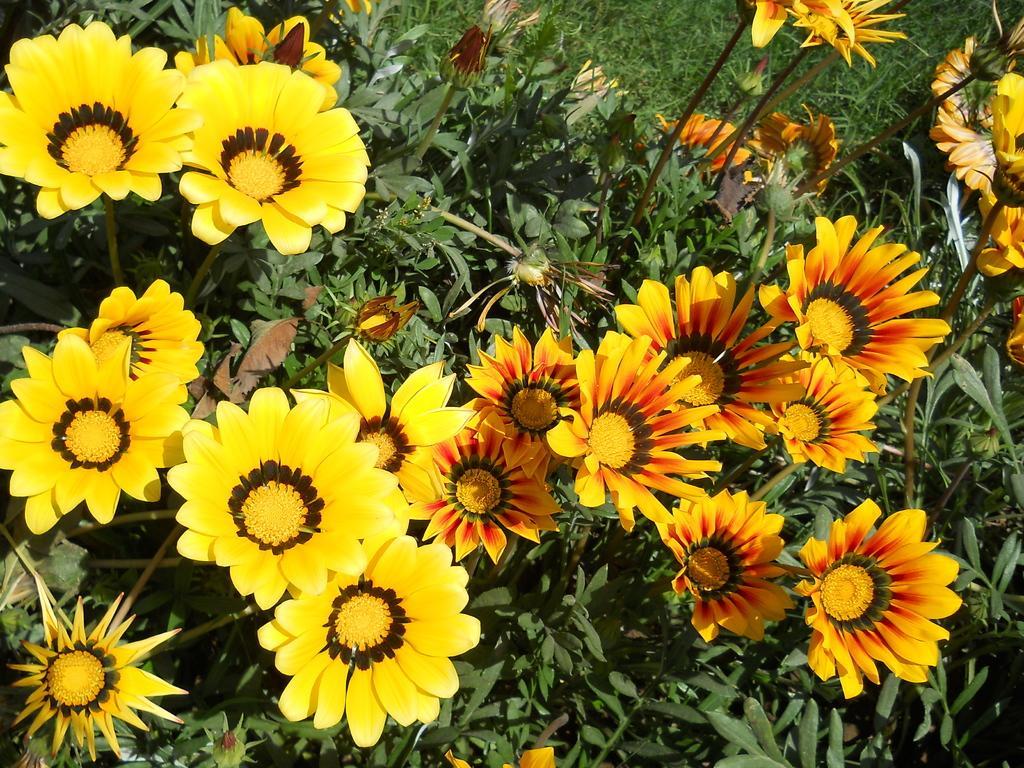Please provide a concise description of this image. In this image in the middle, there are many plants, flowers, leaves and buds. At the top there is grass. 